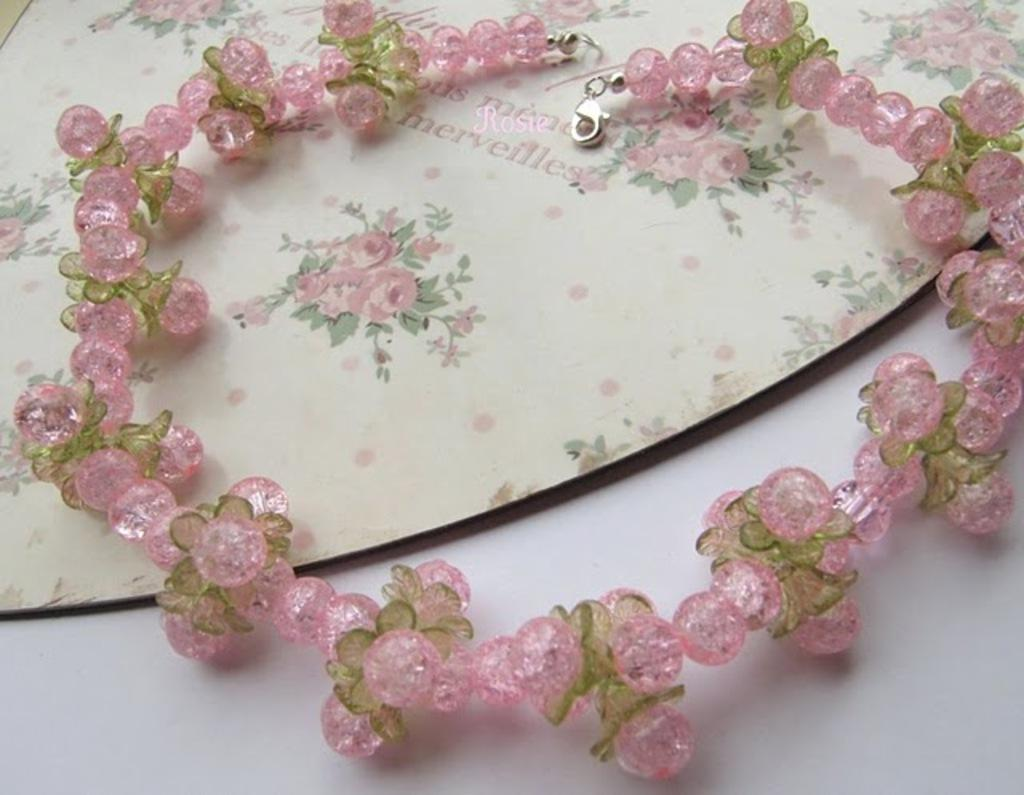What is the main object in the image? There is a chain or necklace in the image. What is the color of the surface at the bottom of the image? The surface at the bottom of the image is white. Can you see any horns on the chain or necklace in the image? There are no horns present on the chain or necklace in the image. What type of furniture is visible in the image? There is no furniture visible in the image; it only features a chain or necklace and a white surface. 